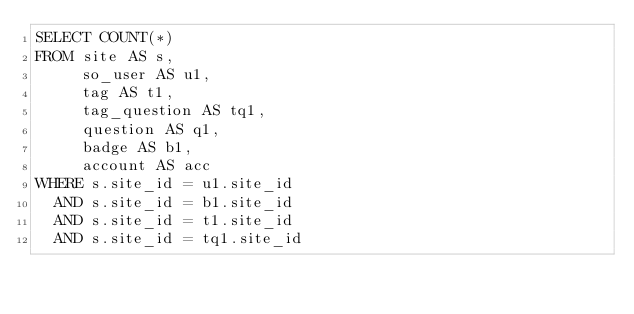Convert code to text. <code><loc_0><loc_0><loc_500><loc_500><_SQL_>SELECT COUNT(*)
FROM site AS s,
     so_user AS u1,
     tag AS t1,
     tag_question AS tq1,
     question AS q1,
     badge AS b1,
     account AS acc
WHERE s.site_id = u1.site_id
  AND s.site_id = b1.site_id
  AND s.site_id = t1.site_id
  AND s.site_id = tq1.site_id</code> 